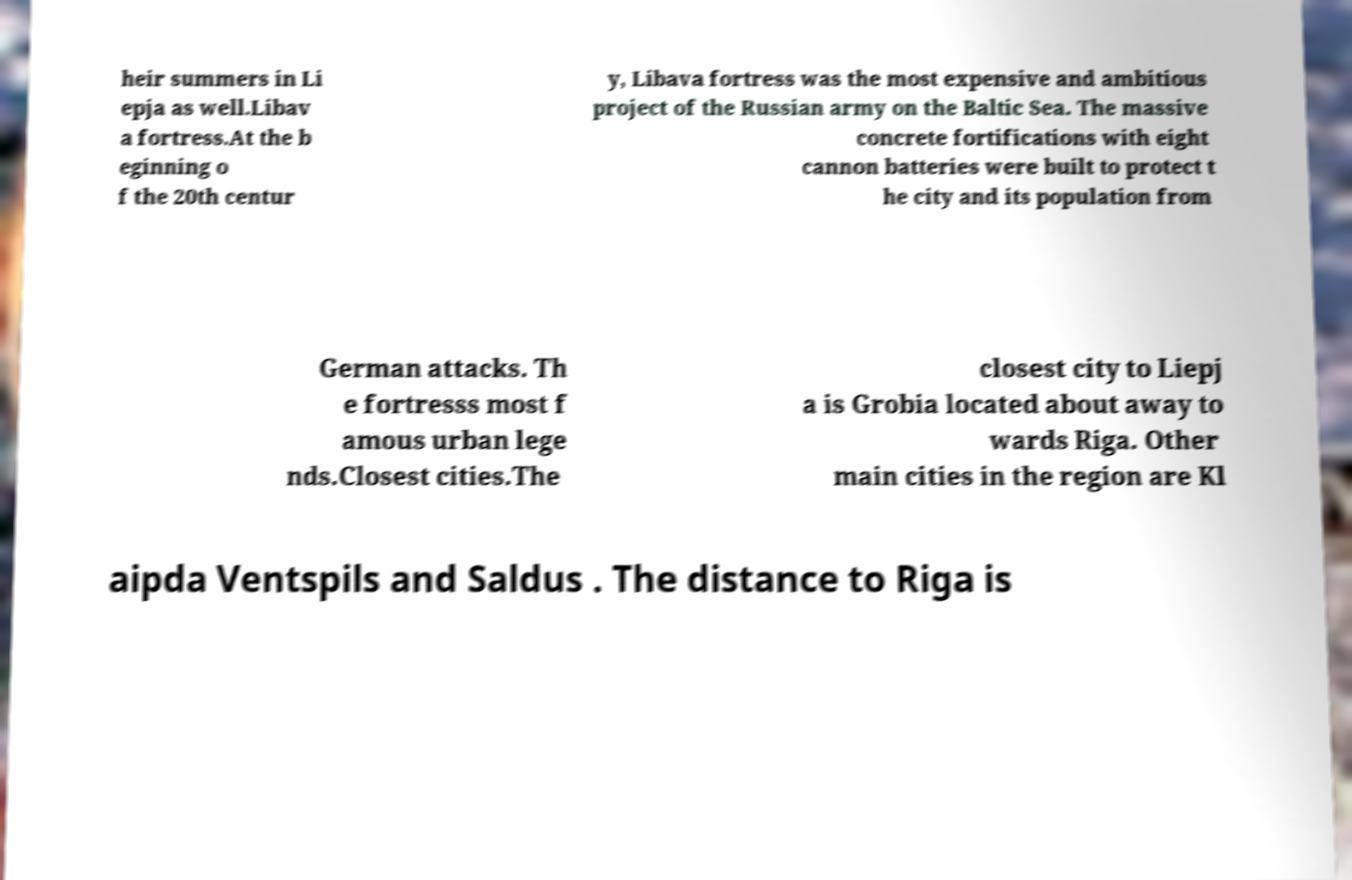For documentation purposes, I need the text within this image transcribed. Could you provide that? heir summers in Li epja as well.Libav a fortress.At the b eginning o f the 20th centur y, Libava fortress was the most expensive and ambitious project of the Russian army on the Baltic Sea. The massive concrete fortifications with eight cannon batteries were built to protect t he city and its population from German attacks. Th e fortresss most f amous urban lege nds.Closest cities.The closest city to Liepj a is Grobia located about away to wards Riga. Other main cities in the region are Kl aipda Ventspils and Saldus . The distance to Riga is 